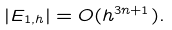Convert formula to latex. <formula><loc_0><loc_0><loc_500><loc_500>| E _ { 1 , h } | = O ( h ^ { 3 n + 1 } ) .</formula> 